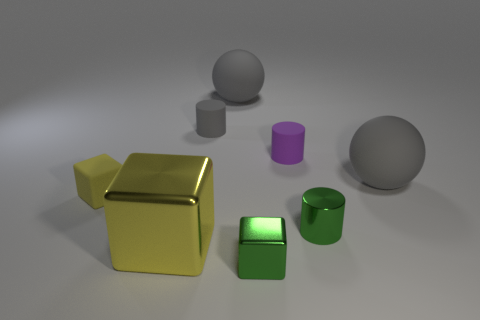How many things are tiny gray things or purple rubber cylinders?
Your answer should be very brief. 2. There is a yellow matte block; does it have the same size as the metallic object right of the small purple rubber object?
Keep it short and to the point. Yes. There is a gray sphere to the left of the large ball on the right side of the metal block that is to the right of the large yellow object; what is its size?
Offer a terse response. Large. Are any tiny brown matte spheres visible?
Offer a very short reply. No. There is a block that is the same color as the tiny shiny cylinder; what is its material?
Provide a succinct answer. Metal. How many big things have the same color as the small matte cube?
Your answer should be compact. 1. How many things are small matte objects on the right side of the big yellow metallic block or big things that are behind the yellow metallic object?
Provide a succinct answer. 4. There is a metal block left of the small shiny block; what number of metallic cylinders are in front of it?
Provide a succinct answer. 0. There is a small block that is the same material as the small green cylinder; what is its color?
Your response must be concise. Green. Is there a rubber cylinder that has the same size as the purple matte thing?
Your response must be concise. Yes. 